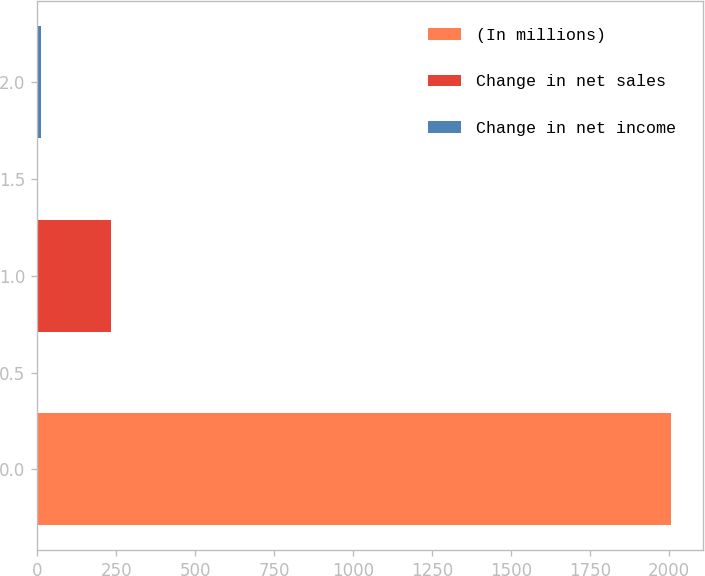Convert chart to OTSL. <chart><loc_0><loc_0><loc_500><loc_500><bar_chart><fcel>(In millions)<fcel>Change in net sales<fcel>Change in net income<nl><fcel>2007<fcel>232<fcel>13<nl></chart> 